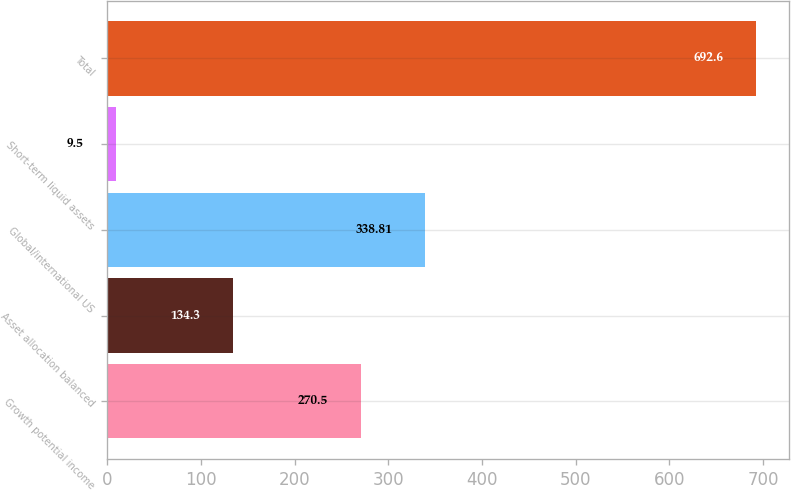<chart> <loc_0><loc_0><loc_500><loc_500><bar_chart><fcel>Growth potential income<fcel>Asset allocation balanced<fcel>Global/international US<fcel>Short-term liquid assets<fcel>Total<nl><fcel>270.5<fcel>134.3<fcel>338.81<fcel>9.5<fcel>692.6<nl></chart> 